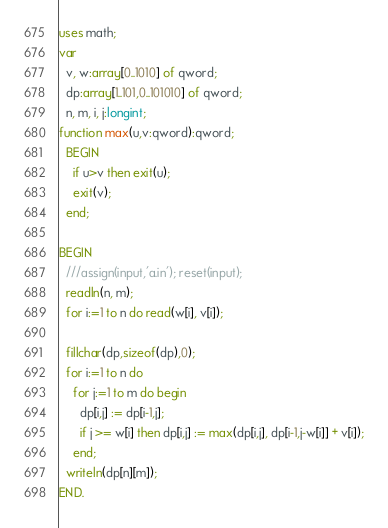<code> <loc_0><loc_0><loc_500><loc_500><_Pascal_>uses math;
var
  v, w:array[0..1010] of qword;
  dp:array[1..101,0..101010] of qword;
  n, m, i, j:longint;
function max(u,v:qword):qword;
  BEGIN
    if u>v then exit(u);
    exit(v);
  end;
  
BEGIN
  ///assign(input,'a.in'); reset(input);
  readln(n, m);
  for i:=1 to n do read(w[i], v[i]);

  fillchar(dp,sizeof(dp),0);
  for i:=1 to n do
    for j:=1 to m do begin
      dp[i,j] := dp[i-1,j];
      if j >= w[i] then dp[i,j] := max(dp[i,j], dp[i-1,j-w[i]] + v[i]);
    end;
  writeln(dp[n][m]);
END.</code> 